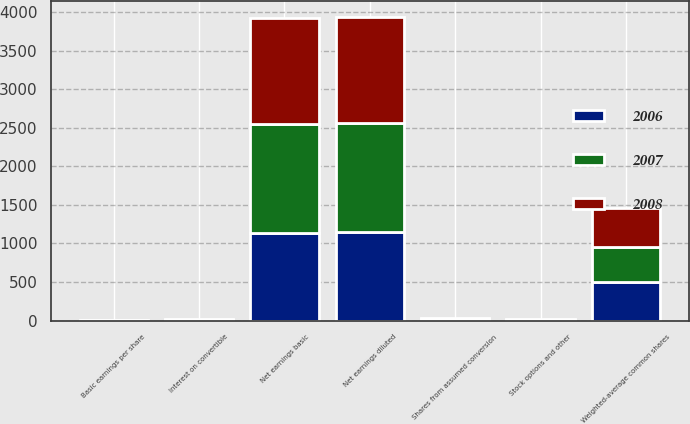Convert chart. <chart><loc_0><loc_0><loc_500><loc_500><stacked_bar_chart><ecel><fcel>Net earnings basic<fcel>Interest on convertible<fcel>Net earnings diluted<fcel>Weighted-average common shares<fcel>Shares from assumed conversion<fcel>Stock options and other<fcel>Basic earnings per share<nl><fcel>2007<fcel>1407<fcel>6<fcel>1413<fcel>452.9<fcel>8.8<fcel>4.2<fcel>3.2<nl><fcel>2008<fcel>1377<fcel>7<fcel>1384<fcel>496.2<fcel>8.8<fcel>5.3<fcel>2.86<nl><fcel>2006<fcel>1140<fcel>7<fcel>1147<fcel>504.8<fcel>8.8<fcel>5.7<fcel>2.33<nl></chart> 